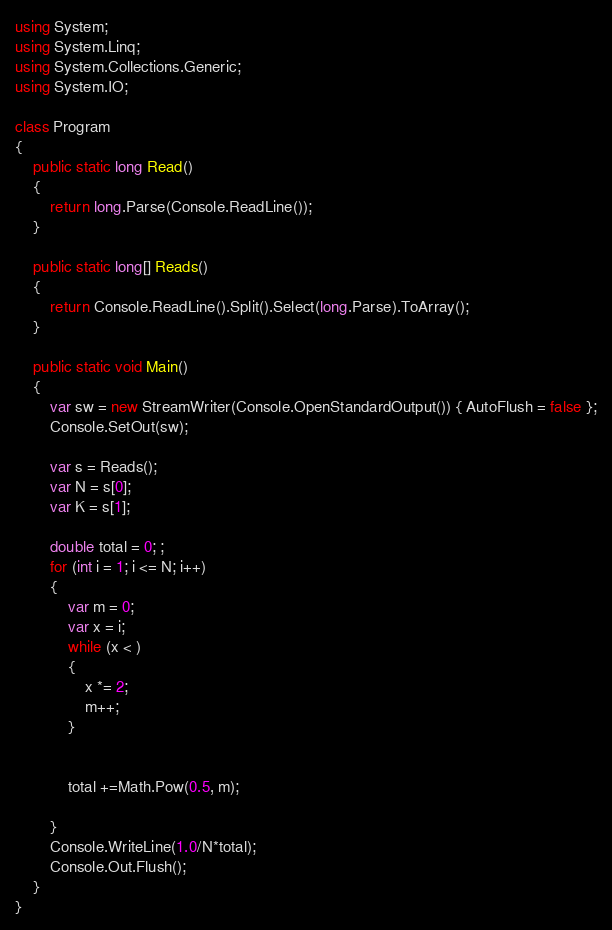<code> <loc_0><loc_0><loc_500><loc_500><_C#_>using System;
using System.Linq;
using System.Collections.Generic;
using System.IO;

class Program
{
    public static long Read()
    {
        return long.Parse(Console.ReadLine());
    }

    public static long[] Reads()
    {
        return Console.ReadLine().Split().Select(long.Parse).ToArray();
    }

    public static void Main()
    {
        var sw = new StreamWriter(Console.OpenStandardOutput()) { AutoFlush = false };
        Console.SetOut(sw);

        var s = Reads();
        var N = s[0];
        var K = s[1];

        double total = 0; ;
        for (int i = 1; i <= N; i++)
        {
            var m = 0;
            var x = i;
            while (x < )
            {
                x *= 2;
                m++;
            }

           
            total +=Math.Pow(0.5, m);
         
        }
        Console.WriteLine(1.0/N*total);
        Console.Out.Flush();
    }
}</code> 